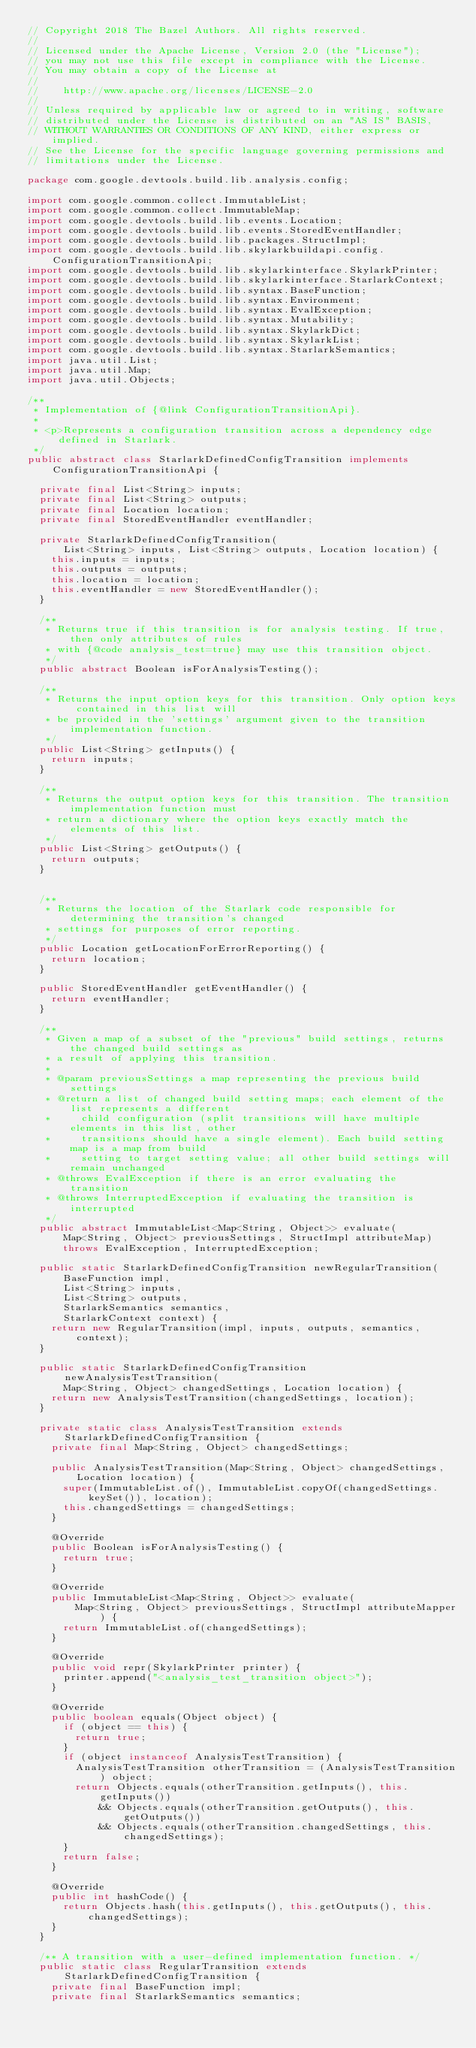<code> <loc_0><loc_0><loc_500><loc_500><_Java_>// Copyright 2018 The Bazel Authors. All rights reserved.
//
// Licensed under the Apache License, Version 2.0 (the "License");
// you may not use this file except in compliance with the License.
// You may obtain a copy of the License at
//
//    http://www.apache.org/licenses/LICENSE-2.0
//
// Unless required by applicable law or agreed to in writing, software
// distributed under the License is distributed on an "AS IS" BASIS,
// WITHOUT WARRANTIES OR CONDITIONS OF ANY KIND, either express or implied.
// See the License for the specific language governing permissions and
// limitations under the License.

package com.google.devtools.build.lib.analysis.config;

import com.google.common.collect.ImmutableList;
import com.google.common.collect.ImmutableMap;
import com.google.devtools.build.lib.events.Location;
import com.google.devtools.build.lib.events.StoredEventHandler;
import com.google.devtools.build.lib.packages.StructImpl;
import com.google.devtools.build.lib.skylarkbuildapi.config.ConfigurationTransitionApi;
import com.google.devtools.build.lib.skylarkinterface.SkylarkPrinter;
import com.google.devtools.build.lib.skylarkinterface.StarlarkContext;
import com.google.devtools.build.lib.syntax.BaseFunction;
import com.google.devtools.build.lib.syntax.Environment;
import com.google.devtools.build.lib.syntax.EvalException;
import com.google.devtools.build.lib.syntax.Mutability;
import com.google.devtools.build.lib.syntax.SkylarkDict;
import com.google.devtools.build.lib.syntax.SkylarkList;
import com.google.devtools.build.lib.syntax.StarlarkSemantics;
import java.util.List;
import java.util.Map;
import java.util.Objects;

/**
 * Implementation of {@link ConfigurationTransitionApi}.
 *
 * <p>Represents a configuration transition across a dependency edge defined in Starlark.
 */
public abstract class StarlarkDefinedConfigTransition implements ConfigurationTransitionApi {

  private final List<String> inputs;
  private final List<String> outputs;
  private final Location location;
  private final StoredEventHandler eventHandler;

  private StarlarkDefinedConfigTransition(
      List<String> inputs, List<String> outputs, Location location) {
    this.inputs = inputs;
    this.outputs = outputs;
    this.location = location;
    this.eventHandler = new StoredEventHandler();
  }

  /**
   * Returns true if this transition is for analysis testing. If true, then only attributes of rules
   * with {@code analysis_test=true} may use this transition object.
   */
  public abstract Boolean isForAnalysisTesting();

  /**
   * Returns the input option keys for this transition. Only option keys contained in this list will
   * be provided in the 'settings' argument given to the transition implementation function.
   */
  public List<String> getInputs() {
    return inputs;
  }

  /**
   * Returns the output option keys for this transition. The transition implementation function must
   * return a dictionary where the option keys exactly match the elements of this list.
   */
  public List<String> getOutputs() {
    return outputs;
  }
  

  /**
   * Returns the location of the Starlark code responsible for determining the transition's changed
   * settings for purposes of error reporting.
   */
  public Location getLocationForErrorReporting() {
    return location;
  }

  public StoredEventHandler getEventHandler() {
    return eventHandler;
  }

  /**
   * Given a map of a subset of the "previous" build settings, returns the changed build settings as
   * a result of applying this transition.
   *
   * @param previousSettings a map representing the previous build settings
   * @return a list of changed build setting maps; each element of the list represents a different
   *     child configuration (split transitions will have multiple elements in this list, other
   *     transitions should have a single element). Each build setting map is a map from build
   *     setting to target setting value; all other build settings will remain unchanged
   * @throws EvalException if there is an error evaluating the transition
   * @throws InterruptedException if evaluating the transition is interrupted
   */
  public abstract ImmutableList<Map<String, Object>> evaluate(
      Map<String, Object> previousSettings, StructImpl attributeMap)
      throws EvalException, InterruptedException;

  public static StarlarkDefinedConfigTransition newRegularTransition(
      BaseFunction impl,
      List<String> inputs,
      List<String> outputs,
      StarlarkSemantics semantics,
      StarlarkContext context) {
    return new RegularTransition(impl, inputs, outputs, semantics, context);
  }

  public static StarlarkDefinedConfigTransition newAnalysisTestTransition(
      Map<String, Object> changedSettings, Location location) {
    return new AnalysisTestTransition(changedSettings, location);
  }

  private static class AnalysisTestTransition extends StarlarkDefinedConfigTransition {
    private final Map<String, Object> changedSettings;

    public AnalysisTestTransition(Map<String, Object> changedSettings, Location location) {
      super(ImmutableList.of(), ImmutableList.copyOf(changedSettings.keySet()), location);
      this.changedSettings = changedSettings;
    }

    @Override
    public Boolean isForAnalysisTesting() {
      return true;
    }

    @Override
    public ImmutableList<Map<String, Object>> evaluate(
        Map<String, Object> previousSettings, StructImpl attributeMapper) {
      return ImmutableList.of(changedSettings);
    }

    @Override
    public void repr(SkylarkPrinter printer) {
      printer.append("<analysis_test_transition object>");
    }

    @Override
    public boolean equals(Object object) {
      if (object == this) {
        return true;
      }
      if (object instanceof AnalysisTestTransition) {
        AnalysisTestTransition otherTransition = (AnalysisTestTransition) object;
        return Objects.equals(otherTransition.getInputs(), this.getInputs())
            && Objects.equals(otherTransition.getOutputs(), this.getOutputs())
            && Objects.equals(otherTransition.changedSettings, this.changedSettings);
      }
      return false;
    }

    @Override
    public int hashCode() {
      return Objects.hash(this.getInputs(), this.getOutputs(), this.changedSettings);
    }
  }

  /** A transition with a user-defined implementation function. */
  public static class RegularTransition extends StarlarkDefinedConfigTransition {
    private final BaseFunction impl;
    private final StarlarkSemantics semantics;</code> 